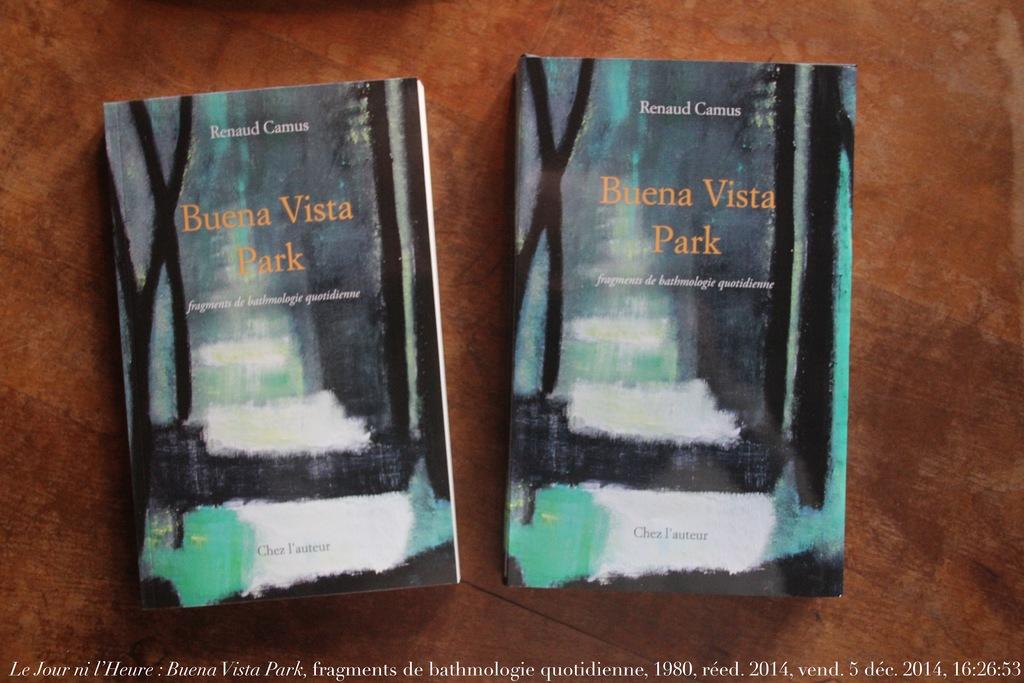What is the name of the park in the title of this book?
Provide a succinct answer. Buena vista park. Who wrote the book?
Your answer should be very brief. Renaud camus. 